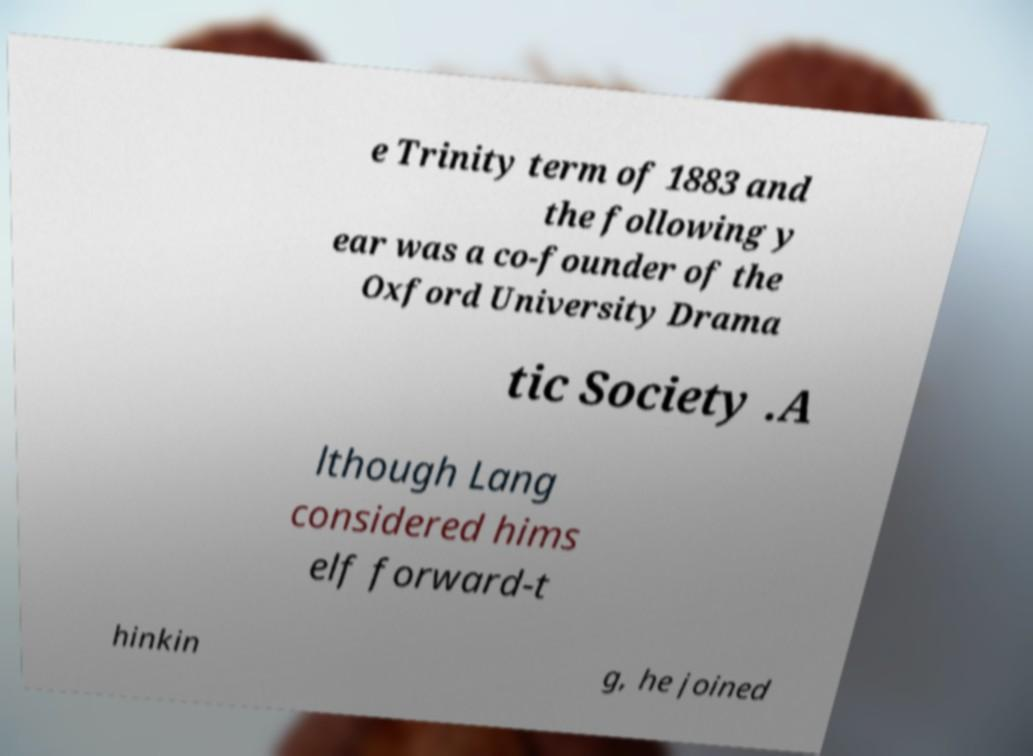What messages or text are displayed in this image? I need them in a readable, typed format. e Trinity term of 1883 and the following y ear was a co-founder of the Oxford University Drama tic Society .A lthough Lang considered hims elf forward-t hinkin g, he joined 